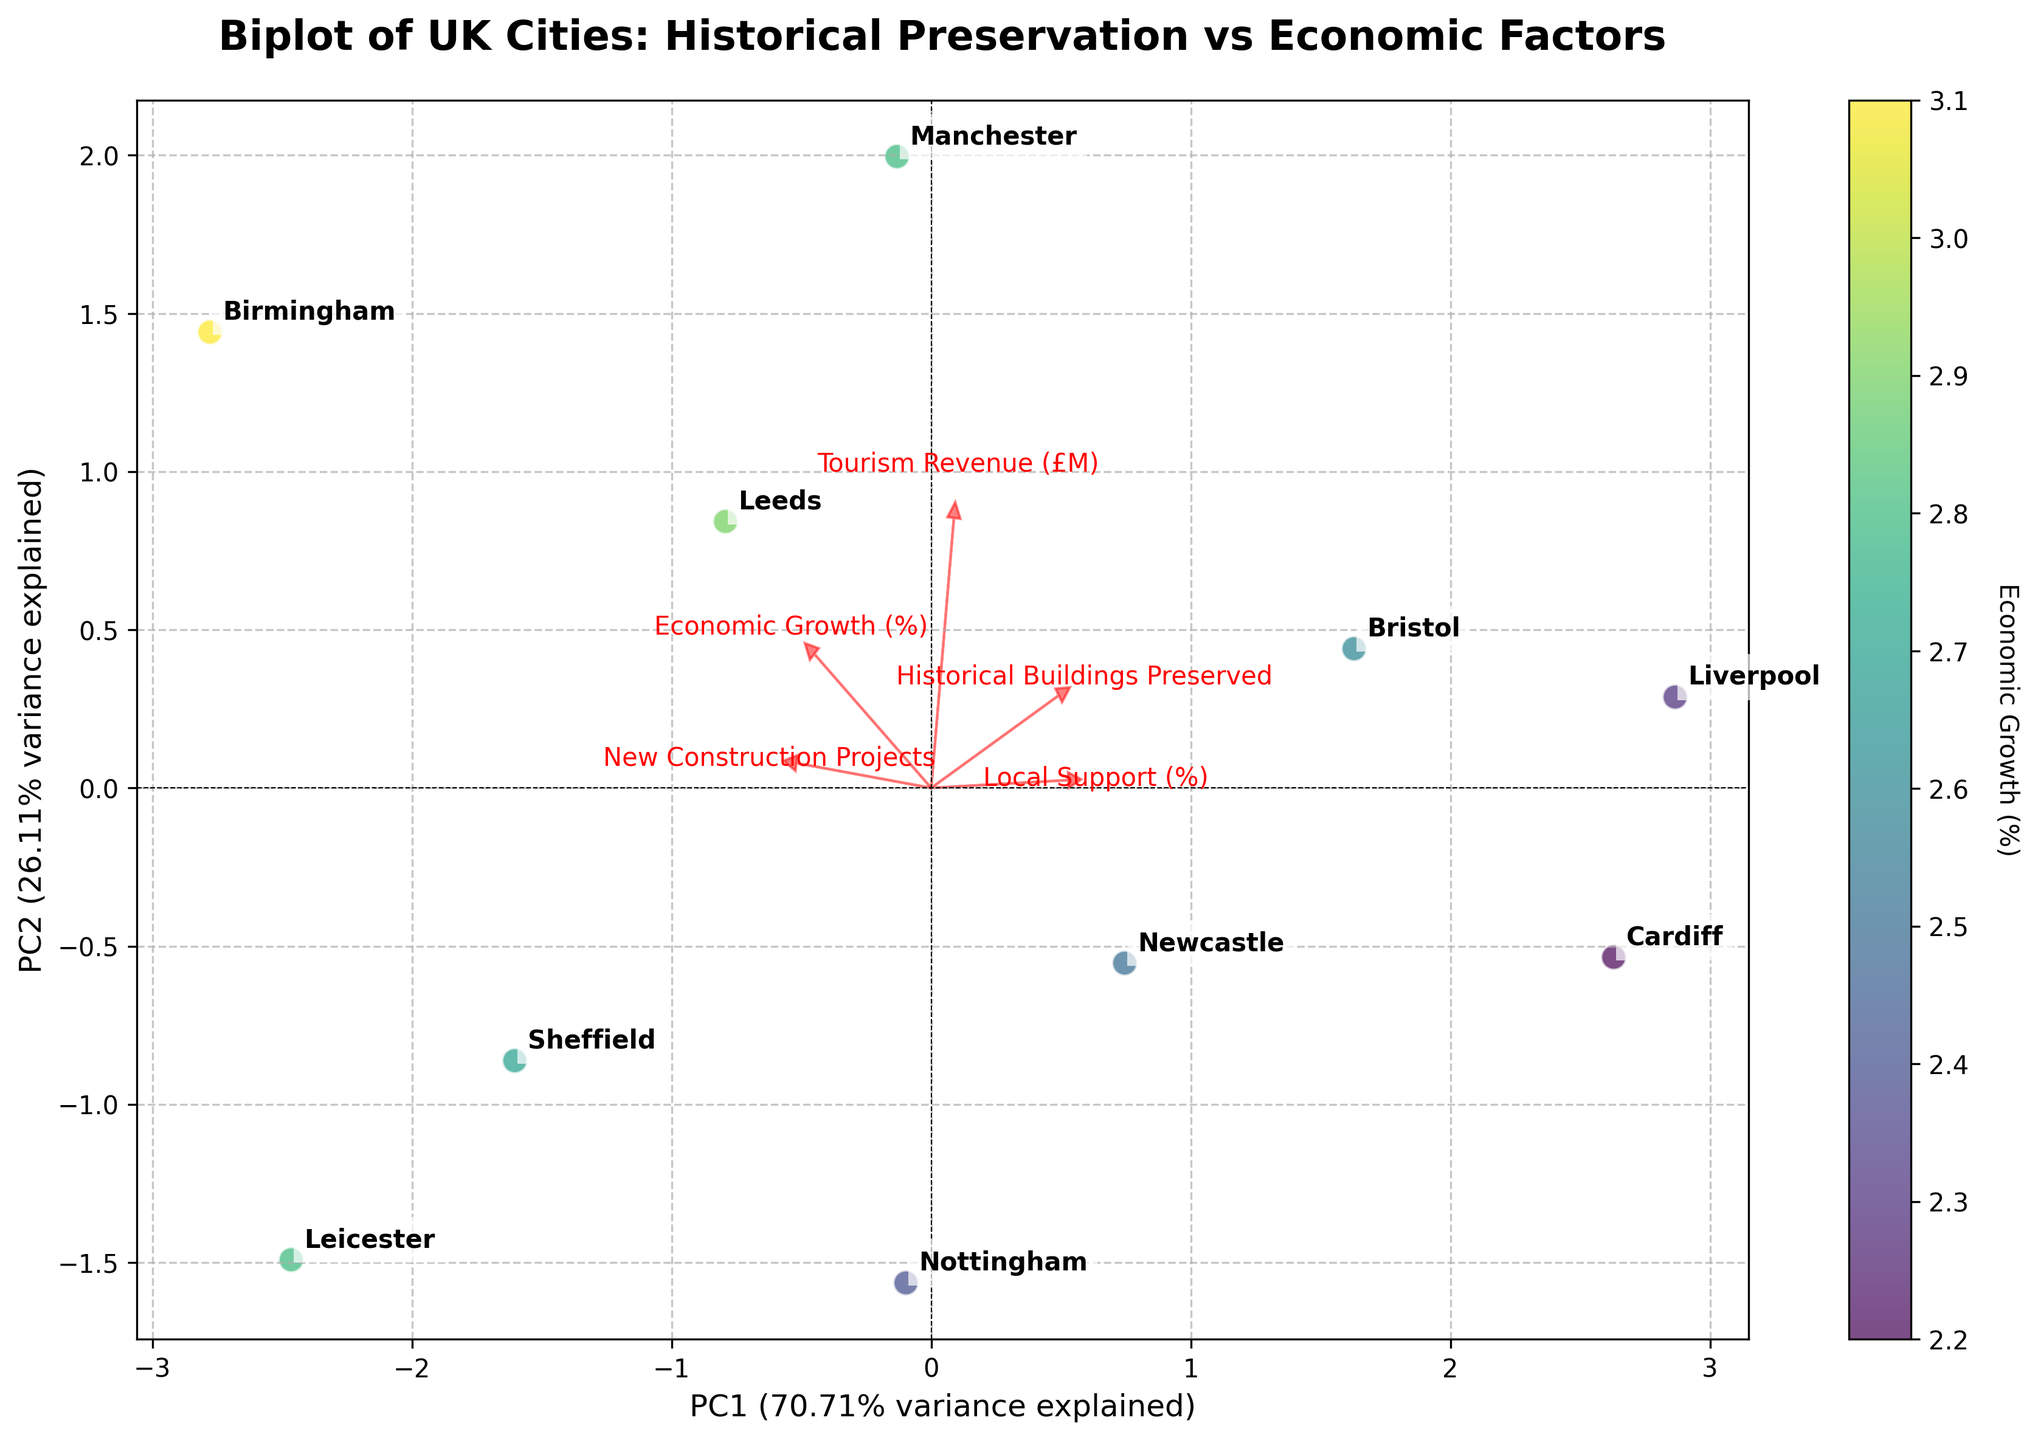What is the main title of the biplot? The main title of the plot is found at the top, usually in bold or a larger font, providing the primary description of the visualization.
Answer: Biplot of UK Cities: Historical Preservation vs Economic Factors How many UK cities are represented in the biplot? Count the number of unique data points labeled with city names in the biplot.
Answer: 10 Which city is associated with the highest economic growth percentage as indicated by the color bar? Identify the city with the darkest color representing the highest economic growth percentage in the color bar legend.
Answer: Birmingham What feature appears to most closely align with PC1 (the first principal component)? Feature alignment with PC1 can be determined by checking which feature vector (arrow) points most directly along the x-axis.
Answer: New Construction Projects Which features negatively correlate with PC2 (the second principal component)? Features negatively correlated with PC2 will have arrows pointing downward along the y-axis.
Answer: Tourism Revenue (£M) and Cardiff City Comparing Manchester and Liverpool, which city has preserved more historical buildings? Find and compare the labeled data points for Manchester and Liverpool and check their positions along the feature vector for 'Historical Buildings Preserved'.
Answer: Liverpool What can you infer about cities with high economic growth in terms of new construction projects? Assess the position and alignment of cities with higher economic growth percentages in relation to the 'New Construction Projects' feature vector.
Answer: Cities with high economic growth tend to have more new construction projects Which city shows a balance between tourism revenue and local support? Identify the city positioned in between the feature vectors for 'Tourism Revenue (£M)' and 'Local Support (%)'.
Answer: Newcastle How does the 'Local Support (%)' feature correlate with PC1 and PC2? Evaluate the direction and length of the 'Local Support (%)' feature arrow relative to the axes PC1 and PC2.
Answer: Positively correlates with PC2 and moderately with PC1 Which feature shows the least influence on PC1? The influence on PC1 is determined by the length and direction of the feature arrows; the shortest arrow will show the least influence.
Answer: Historical Buildings Preserved 